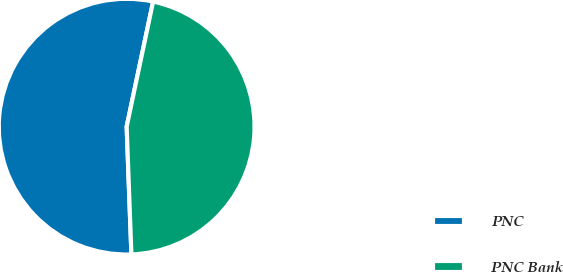<chart> <loc_0><loc_0><loc_500><loc_500><pie_chart><fcel>PNC<fcel>PNC Bank<nl><fcel>53.91%<fcel>46.09%<nl></chart> 